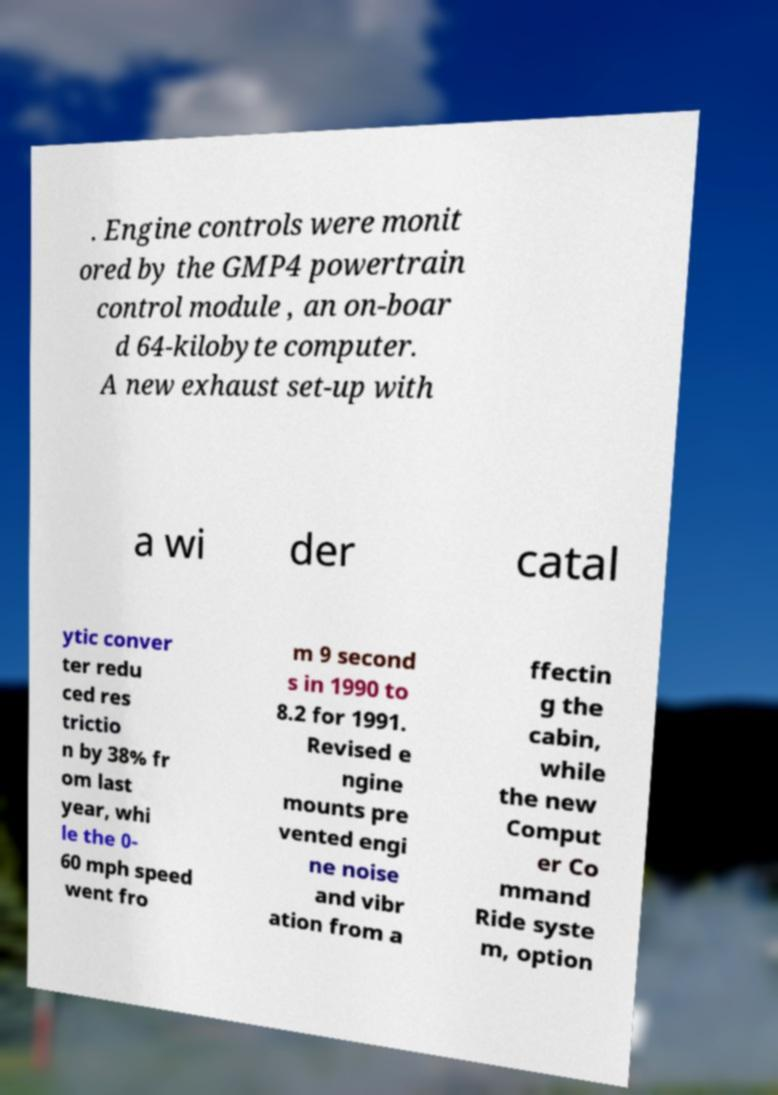Can you read and provide the text displayed in the image?This photo seems to have some interesting text. Can you extract and type it out for me? . Engine controls were monit ored by the GMP4 powertrain control module , an on-boar d 64-kilobyte computer. A new exhaust set-up with a wi der catal ytic conver ter redu ced res trictio n by 38% fr om last year, whi le the 0- 60 mph speed went fro m 9 second s in 1990 to 8.2 for 1991. Revised e ngine mounts pre vented engi ne noise and vibr ation from a ffectin g the cabin, while the new Comput er Co mmand Ride syste m, option 